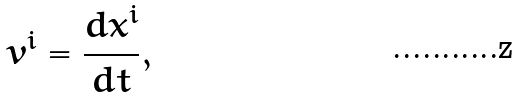<formula> <loc_0><loc_0><loc_500><loc_500>v ^ { i } = \frac { d x ^ { i } } { d t } ,</formula> 